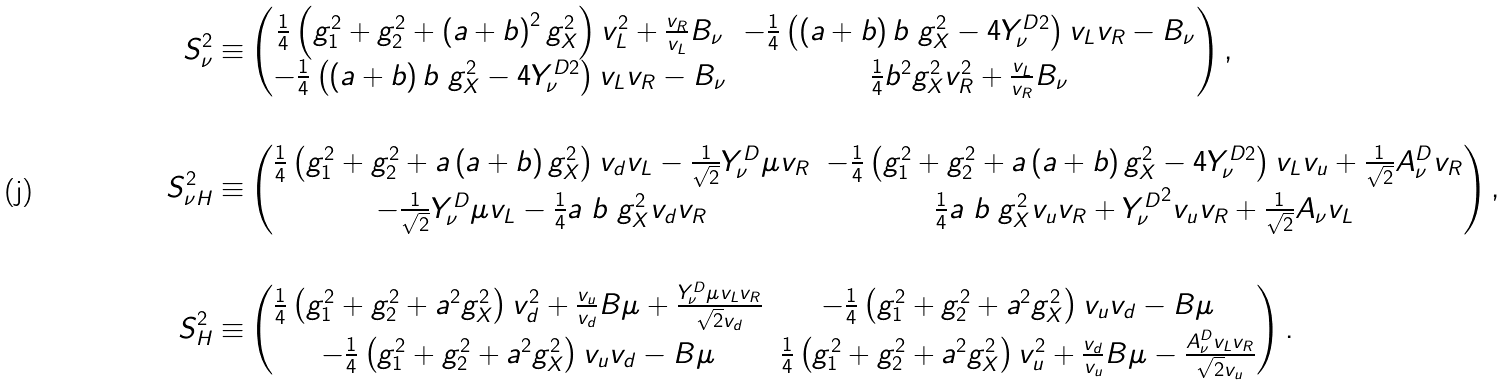Convert formula to latex. <formula><loc_0><loc_0><loc_500><loc_500>S _ { \nu } ^ { 2 } \equiv & \begin{pmatrix} \frac { 1 } { 4 } \left ( g _ { 1 } ^ { 2 } + g _ { 2 } ^ { 2 } + \left ( a + b \right ) ^ { 2 } g _ { X } ^ { 2 } \right ) v _ { L } ^ { 2 } + \frac { v _ { R } } { v _ { L } } B _ { \nu } & - \frac { 1 } { 4 } \left ( \left ( a + b \right ) b \ g _ { X } ^ { 2 } - 4 Y _ { \nu } ^ { D 2 } \right ) v _ { L } v _ { R } - B _ { \nu } \\ - \frac { 1 } { 4 } \left ( \left ( a + b \right ) b \ g _ { X } ^ { 2 } - 4 Y _ { \nu } ^ { D 2 } \right ) v _ { L } v _ { R } - B _ { \nu } & \frac { 1 } { 4 } b ^ { 2 } g _ { X } ^ { 2 } v _ { R } ^ { 2 } + \frac { v _ { L } } { v _ { R } } B _ { \nu } \end{pmatrix} , \\ \\ S _ { \nu H } ^ { 2 } \equiv & \begin{pmatrix} \frac { 1 } { 4 } \left ( g _ { 1 } ^ { 2 } + g _ { 2 } ^ { 2 } + a \left ( a + b \right ) g _ { X } ^ { 2 } \right ) v _ { d } v _ { L } - \frac { 1 } { \sqrt { 2 } } Y _ { \nu } ^ { D } \mu v _ { R } & - \frac { 1 } { 4 } \left ( g _ { 1 } ^ { 2 } + g _ { 2 } ^ { 2 } + a \left ( a + b \right ) g _ { X } ^ { 2 } - 4 Y _ { \nu } ^ { D 2 } \right ) v _ { L } v _ { u } + \frac { 1 } { \sqrt { 2 } } A _ { \nu } ^ { D } v _ { R } \\ - \frac { 1 } { \sqrt { 2 } } Y _ { \nu } ^ { D } \mu v _ { L } - \frac { 1 } { 4 } a \ b \ g _ { X } ^ { 2 } v _ { d } v _ { R } & \frac { 1 } { 4 } a \ b \ g _ { X } ^ { 2 } v _ { u } v _ { R } + { Y _ { \nu } ^ { D } } ^ { 2 } v _ { u } v _ { R } + \frac { 1 } { \sqrt { 2 } } A _ { \nu } v _ { L } \end{pmatrix} , \\ \\ S _ { H } ^ { 2 } \equiv & \begin{pmatrix} \frac { 1 } { 4 } \left ( g _ { 1 } ^ { 2 } + g _ { 2 } ^ { 2 } + a ^ { 2 } g _ { X } ^ { 2 } \right ) v _ { d } ^ { 2 } + \frac { v _ { u } } { v _ { d } } B \mu + \frac { Y _ { \nu } ^ { D } \mu v _ { L } v _ { R } } { \sqrt { 2 } v _ { d } } & - \frac { 1 } { 4 } \left ( g _ { 1 } ^ { 2 } + g _ { 2 } ^ { 2 } + a ^ { 2 } g _ { X } ^ { 2 } \right ) v _ { u } v _ { d } - B \mu \\ - \frac { 1 } { 4 } \left ( g _ { 1 } ^ { 2 } + g _ { 2 } ^ { 2 } + a ^ { 2 } g _ { X } ^ { 2 } \right ) v _ { u } v _ { d } - B \mu & \frac { 1 } { 4 } \left ( g _ { 1 } ^ { 2 } + g _ { 2 } ^ { 2 } + a ^ { 2 } g _ { X } ^ { 2 } \right ) v _ { u } ^ { 2 } + \frac { v _ { d } } { v _ { u } } B \mu - \frac { A _ { \nu } ^ { D } v _ { L } v _ { R } } { \sqrt { 2 } v _ { u } } \end{pmatrix} .</formula> 